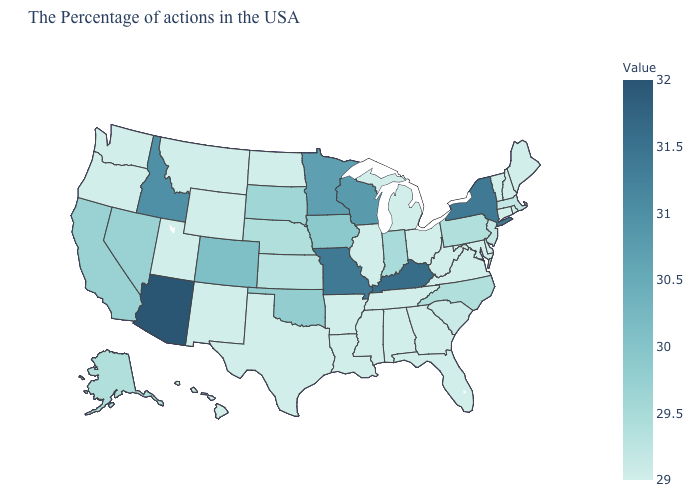Among the states that border Connecticut , which have the highest value?
Short answer required. New York. Among the states that border Tennessee , does Georgia have the lowest value?
Give a very brief answer. Yes. 